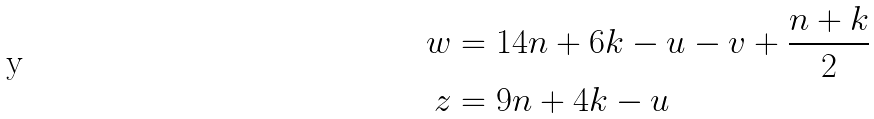Convert formula to latex. <formula><loc_0><loc_0><loc_500><loc_500>w & = 1 4 n + 6 k - u - v + \frac { n + k } { 2 } \\ z & = 9 n + 4 k - u</formula> 